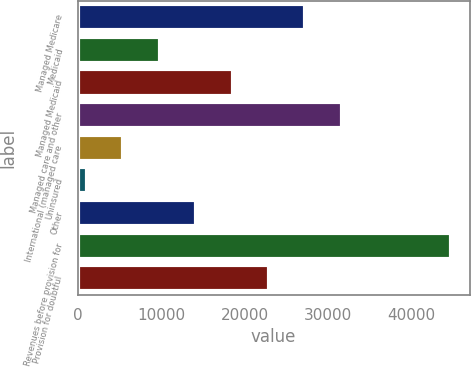Convert chart to OTSL. <chart><loc_0><loc_0><loc_500><loc_500><bar_chart><fcel>Managed Medicare<fcel>Medicaid<fcel>Managed Medicaid<fcel>Managed care and other<fcel>International (managed care<fcel>Uninsured<fcel>Other<fcel>Revenues before provision for<fcel>Provision for doubtful<nl><fcel>27302.2<fcel>9857.4<fcel>18579.8<fcel>31663.4<fcel>5496.2<fcel>1135<fcel>14218.6<fcel>44747<fcel>22941<nl></chart> 